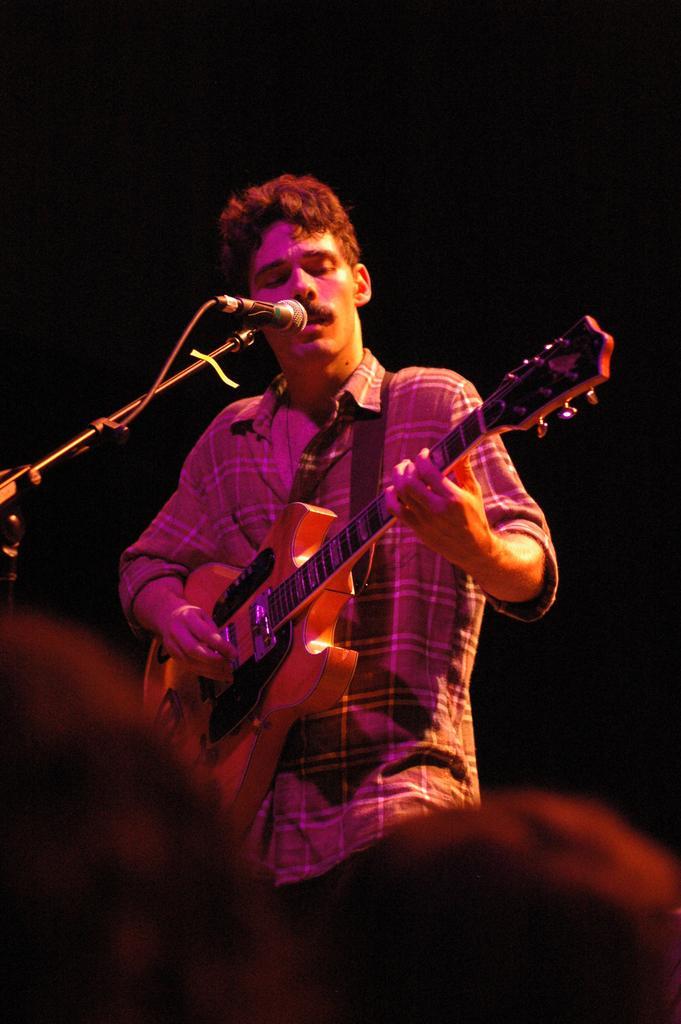Could you give a brief overview of what you see in this image? In this image, there is a person standing in front of the mic and playing a guitar. This person is wearing clothes. 